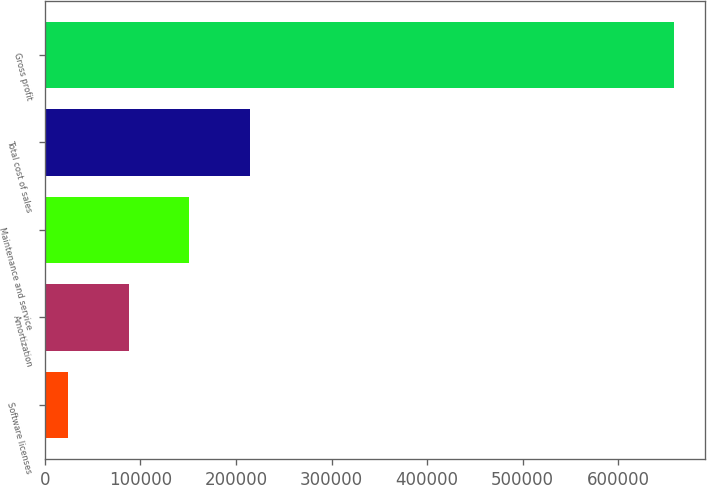Convert chart to OTSL. <chart><loc_0><loc_0><loc_500><loc_500><bar_chart><fcel>Software licenses<fcel>Amortization<fcel>Maintenance and service<fcel>Total cost of sales<fcel>Gross profit<nl><fcel>24512<fcel>87911<fcel>151310<fcel>214709<fcel>658502<nl></chart> 